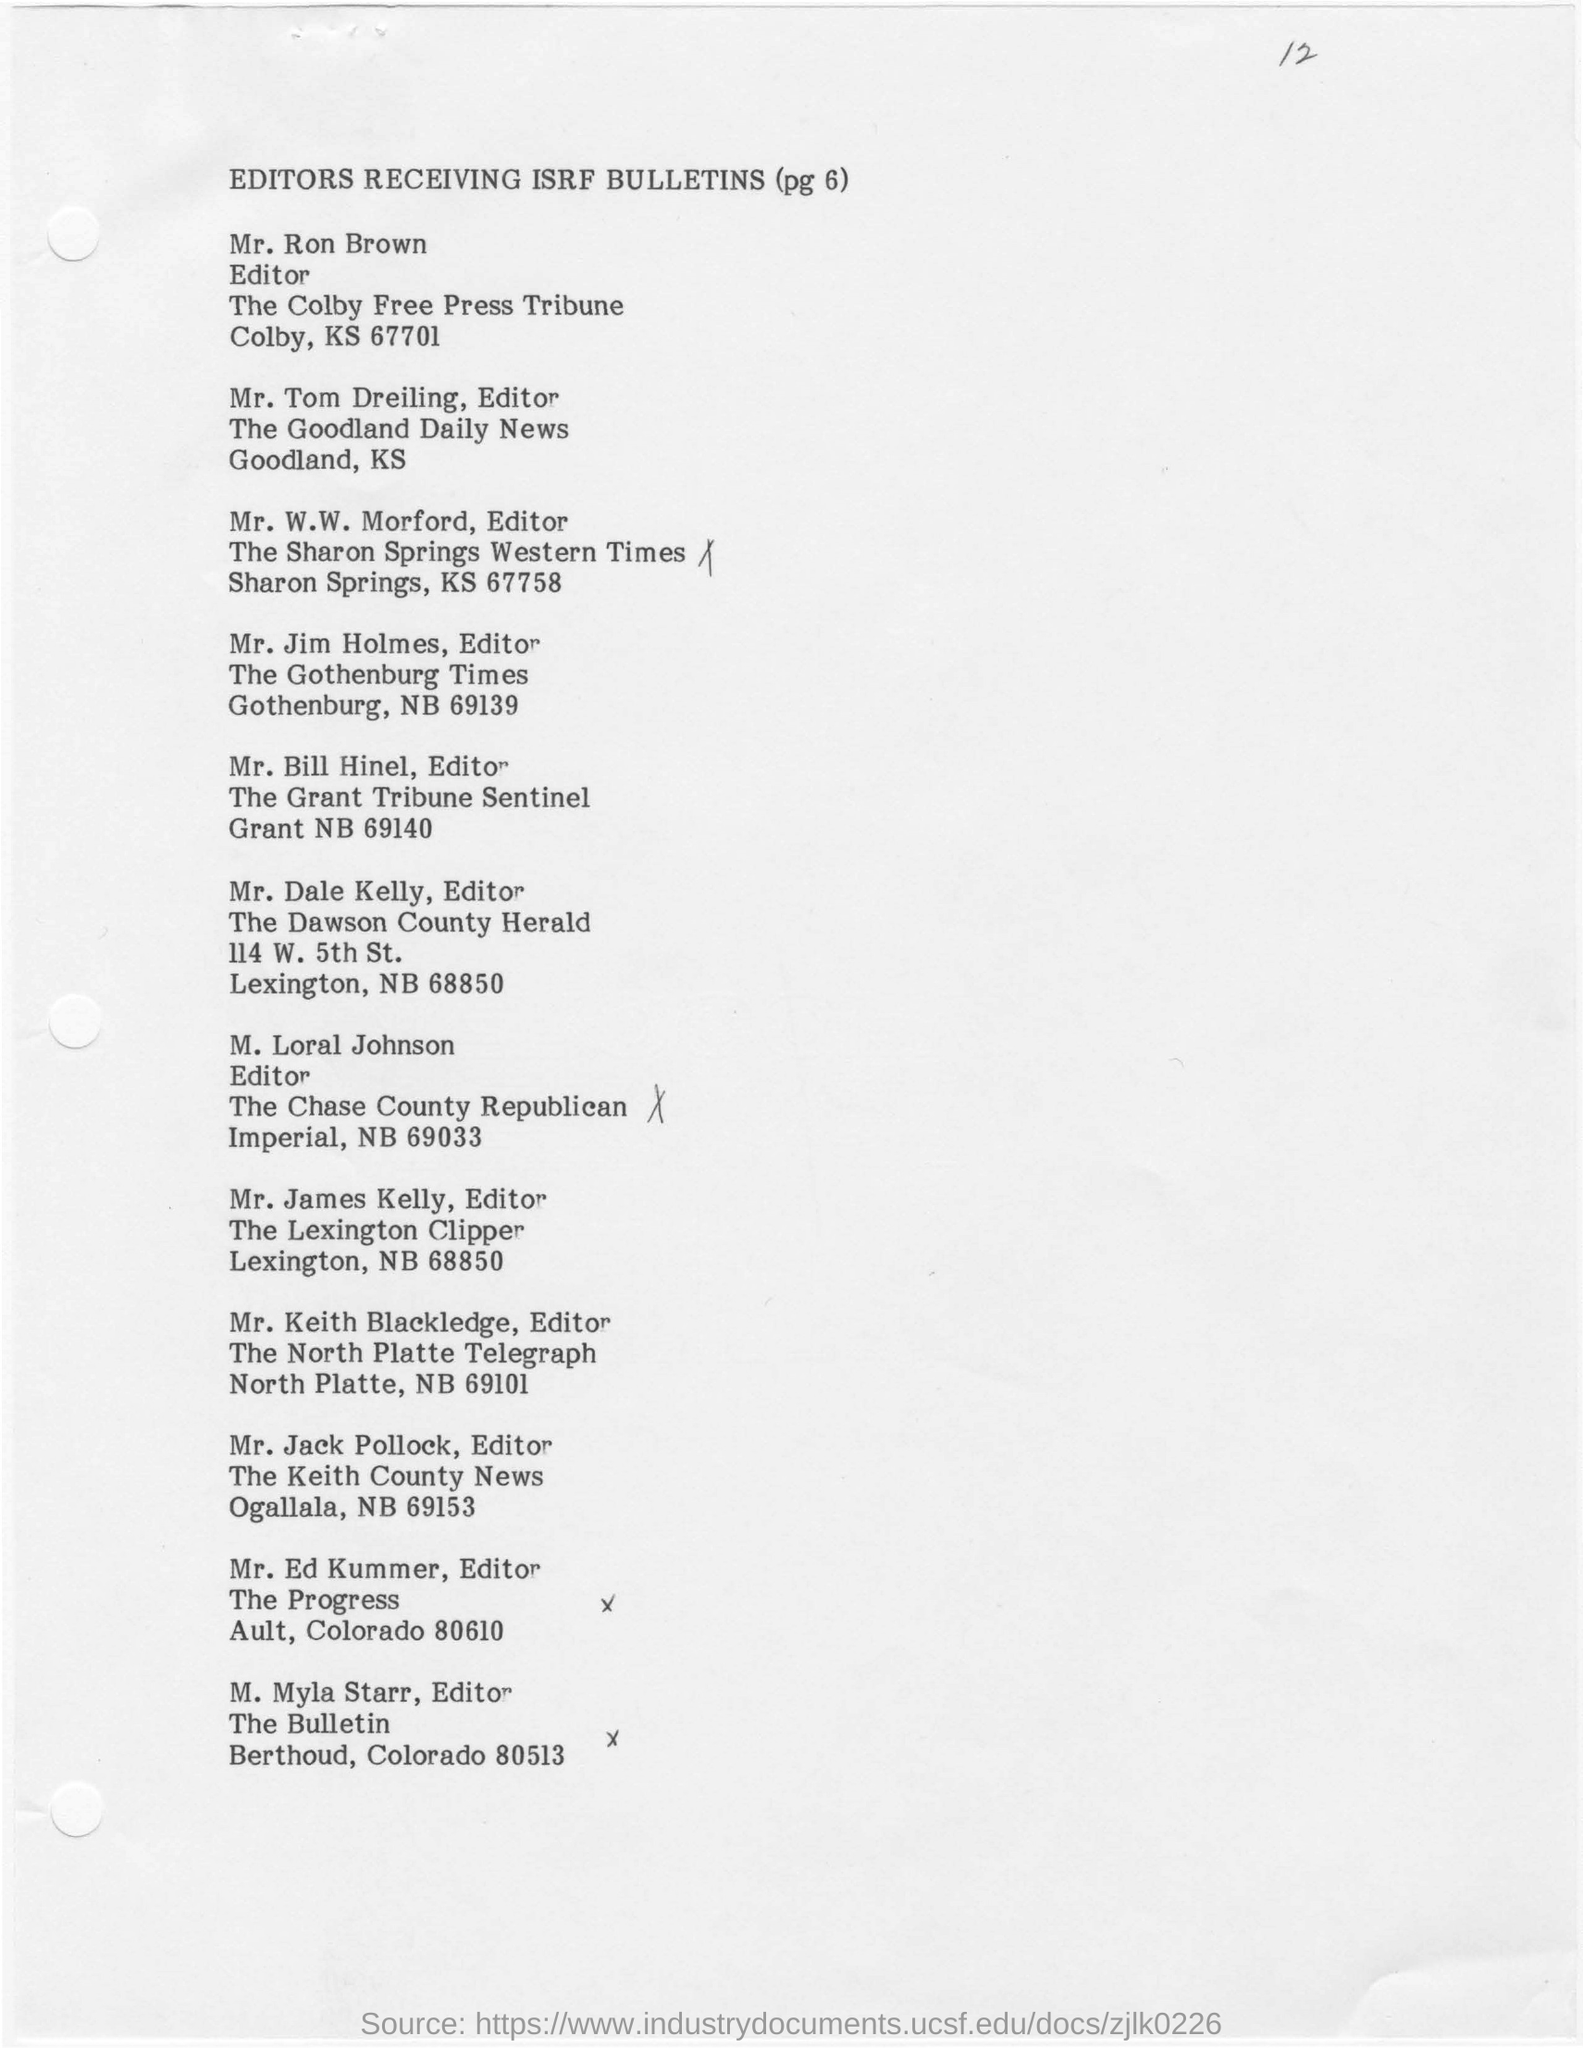Who is the editor of the "the chase country republican"?
Provide a succinct answer. M. Loral Johnson. 